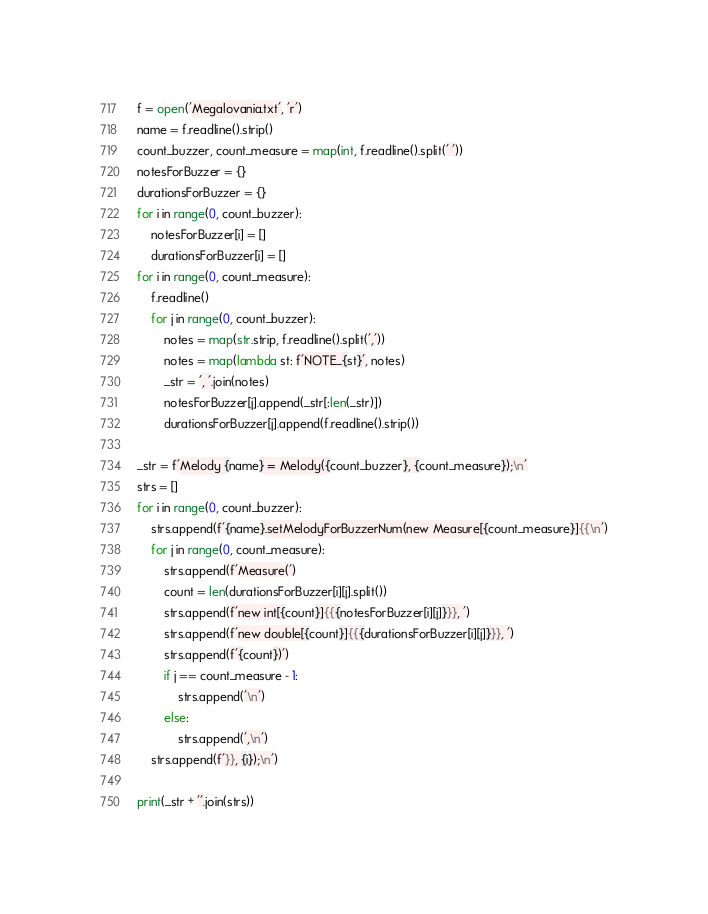<code> <loc_0><loc_0><loc_500><loc_500><_Python_>f = open('Megalovania.txt', 'r')
name = f.readline().strip()
count_buzzer, count_measure = map(int, f.readline().split(' '))
notesForBuzzer = {}
durationsForBuzzer = {}
for i in range(0, count_buzzer):
    notesForBuzzer[i] = []
    durationsForBuzzer[i] = []
for i in range(0, count_measure):
    f.readline()
    for j in range(0, count_buzzer):
        notes = map(str.strip, f.readline().split(','))
        notes = map(lambda st: f'NOTE_{st}', notes)
        _str = ', '.join(notes)
        notesForBuzzer[j].append(_str[:len(_str)])
        durationsForBuzzer[j].append(f.readline().strip())
    
_str = f'Melody {name} = Melody({count_buzzer}, {count_measure});\n'
strs = [] 
for i in range(0, count_buzzer):
    strs.append(f'{name}.setMelodyForBuzzerNum(new Measure[{count_measure}]{{\n')
    for j in range(0, count_measure):
        strs.append(f'Measure(')
        count = len(durationsForBuzzer[i][j].split())
        strs.append(f'new int[{count}]{{{notesForBuzzer[i][j]}}}, ')
        strs.append(f'new double[{count}]{{{durationsForBuzzer[i][j]}}}, ')
        strs.append(f'{count})')
        if j == count_measure - 1:
            strs.append('\n')
        else:
            strs.append(',\n')
    strs.append(f'}}, {i});\n') 

print(_str + ''.join(strs))</code> 